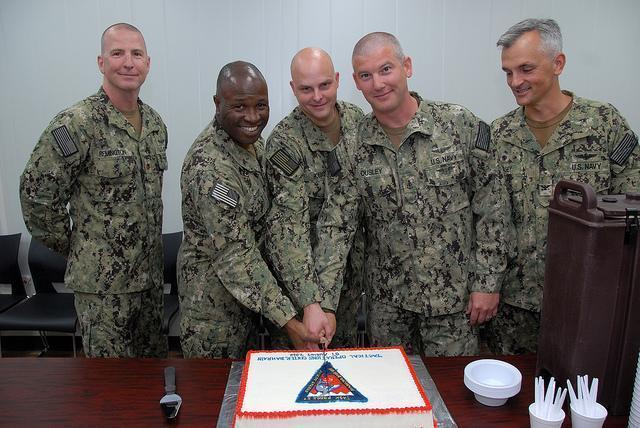How many people are there?
Give a very brief answer. 5. 